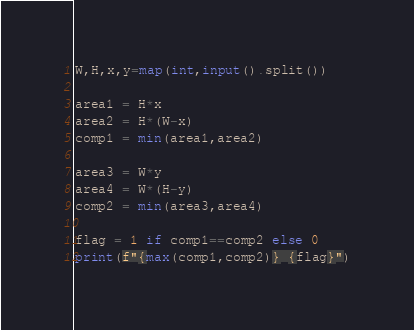<code> <loc_0><loc_0><loc_500><loc_500><_Python_>W,H,x,y=map(int,input().split())

area1 = H*x
area2 = H*(W-x)
comp1 = min(area1,area2)

area3 = W*y
area4 = W*(H-y)
comp2 = min(area3,area4)

flag = 1 if comp1==comp2 else 0
print(f"{max(comp1,comp2)} {flag}")</code> 